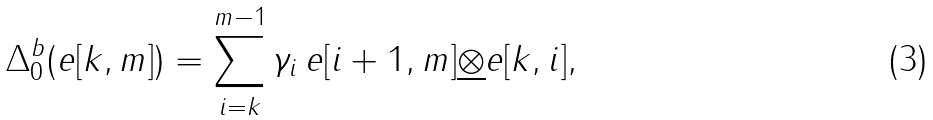<formula> <loc_0><loc_0><loc_500><loc_500>\Delta ^ { b } _ { 0 } ( e [ k , m ] ) = \sum _ { i = k } ^ { m - 1 } \gamma _ { i } \, e [ i + 1 , m ] \underline { \otimes } e [ k , i ] ,</formula> 